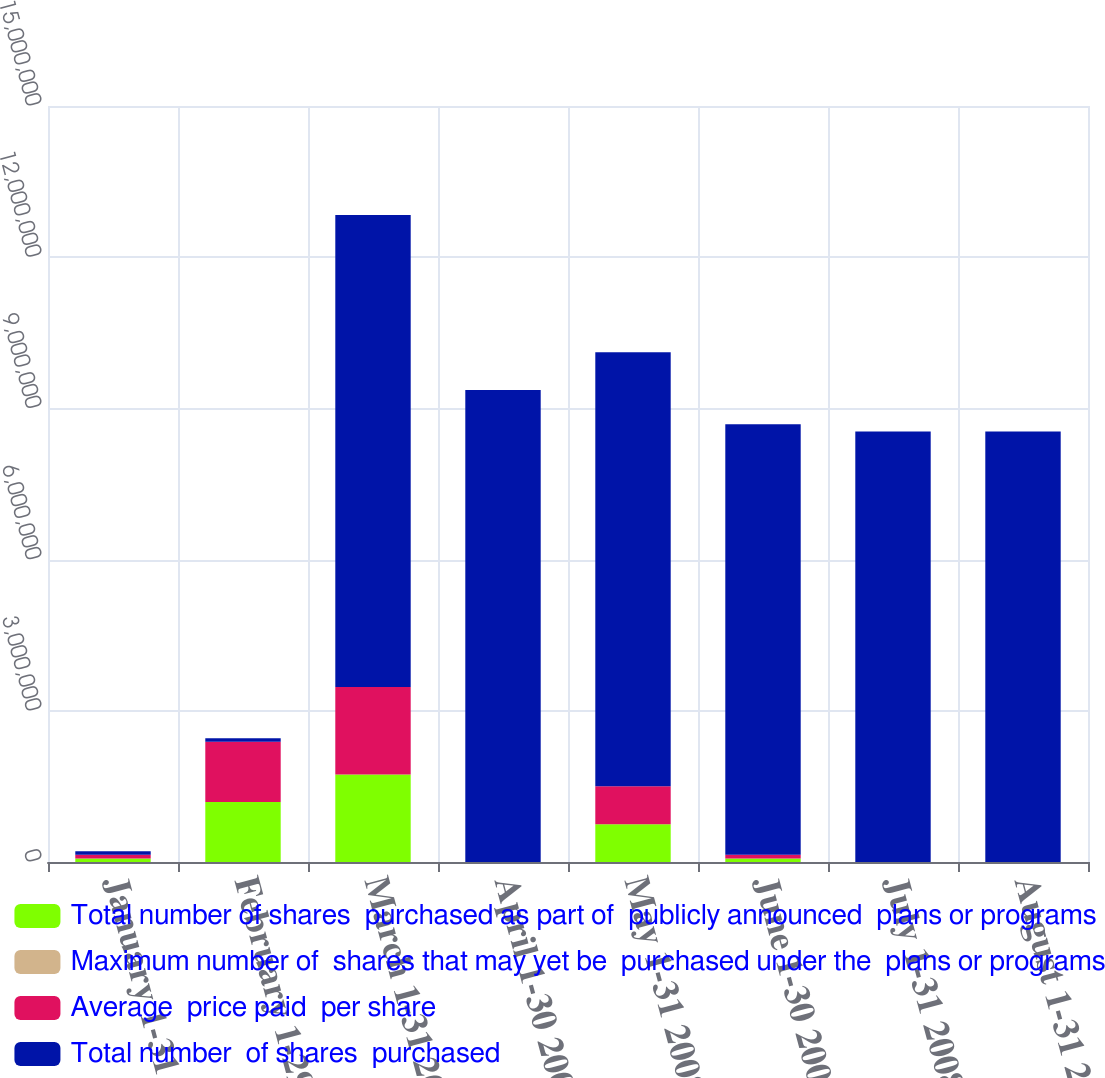Convert chart. <chart><loc_0><loc_0><loc_500><loc_500><stacked_bar_chart><ecel><fcel>January 1-31 2008<fcel>February 1-29 2008<fcel>March 1-31 2008<fcel>April 1-30 2008<fcel>May 1-31 2008<fcel>June 1-30 2008<fcel>July 1-31 2008<fcel>August 1-31 2008<nl><fcel>Total number of shares  purchased as part of  publicly announced  plans or programs<fcel>71003<fcel>1.1922e+06<fcel>1.7368e+06<fcel>0<fcel>750957<fcel>71003<fcel>0<fcel>0<nl><fcel>Maximum number of  shares that may yet be  purchased under the  plans or programs<fcel>0<fcel>37.51<fcel>37.15<fcel>0<fcel>35.88<fcel>34.59<fcel>0<fcel>0<nl><fcel>Average  price paid  per share<fcel>71003<fcel>1.1922e+06<fcel>1.7368e+06<fcel>0<fcel>750000<fcel>71003<fcel>0<fcel>0<nl><fcel>Total number  of shares  purchased<fcel>71003<fcel>71003<fcel>9.36461e+06<fcel>9.36461e+06<fcel>8.61461e+06<fcel>8.54361e+06<fcel>8.54361e+06<fcel>8.54361e+06<nl></chart> 